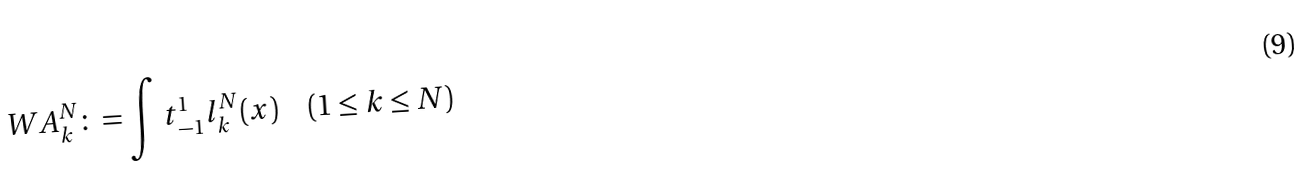Convert formula to latex. <formula><loc_0><loc_0><loc_500><loc_500>\ W A _ { k } ^ { N } \colon = \int t { _ { - 1 } ^ { 1 } l _ { k } ^ { N } ( x ) } \quad ( 1 \leq k \leq N )</formula> 